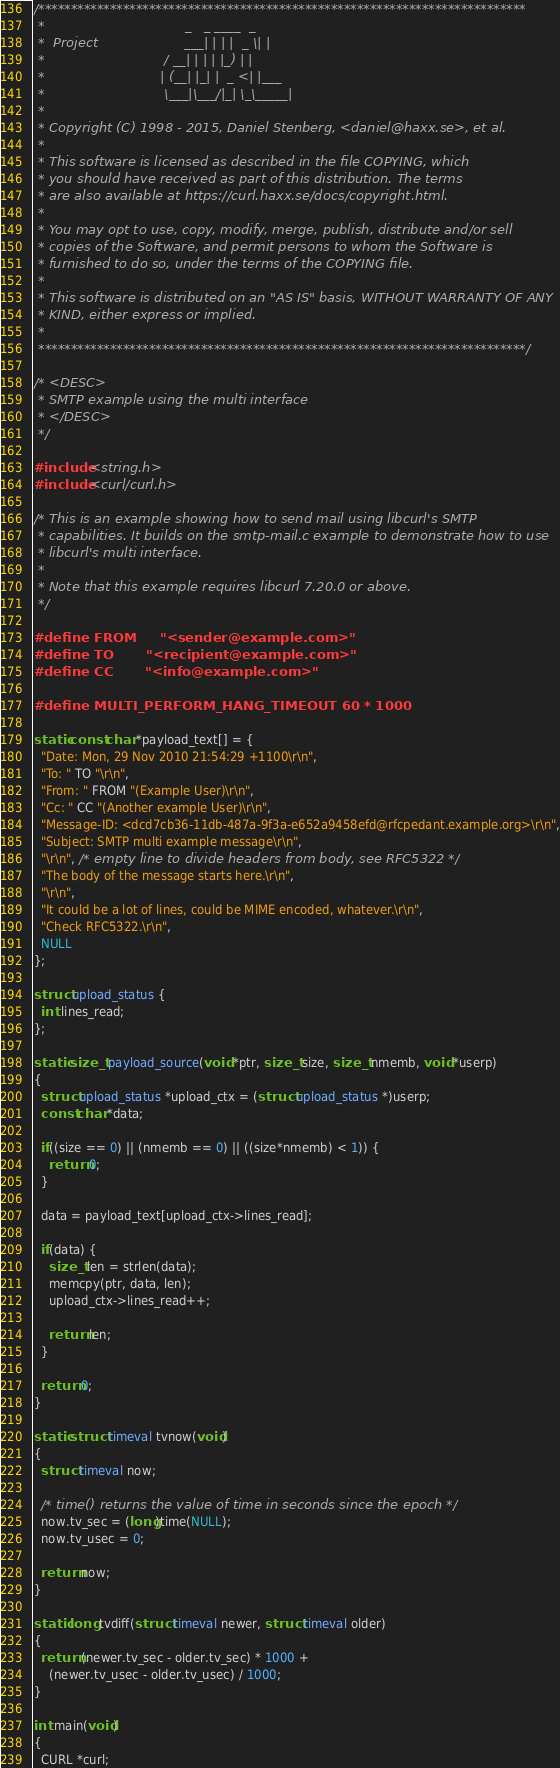Convert code to text. <code><loc_0><loc_0><loc_500><loc_500><_C_>/***************************************************************************
 *                                  _   _ ____  _
 *  Project                     ___| | | |  _ \| |
 *                             / __| | | | |_) | |
 *                            | (__| |_| |  _ <| |___
 *                             \___|\___/|_| \_\_____|
 *
 * Copyright (C) 1998 - 2015, Daniel Stenberg, <daniel@haxx.se>, et al.
 *
 * This software is licensed as described in the file COPYING, which
 * you should have received as part of this distribution. The terms
 * are also available at https://curl.haxx.se/docs/copyright.html.
 *
 * You may opt to use, copy, modify, merge, publish, distribute and/or sell
 * copies of the Software, and permit persons to whom the Software is
 * furnished to do so, under the terms of the COPYING file.
 *
 * This software is distributed on an "AS IS" basis, WITHOUT WARRANTY OF ANY
 * KIND, either express or implied.
 *
 ***************************************************************************/

/* <DESC>
 * SMTP example using the multi interface
 * </DESC>
 */

#include <string.h>
#include <curl/curl.h>

/* This is an example showing how to send mail using libcurl's SMTP
 * capabilities. It builds on the smtp-mail.c example to demonstrate how to use
 * libcurl's multi interface.
 *
 * Note that this example requires libcurl 7.20.0 or above.
 */

#define FROM     "<sender@example.com>"
#define TO       "<recipient@example.com>"
#define CC       "<info@example.com>"

#define MULTI_PERFORM_HANG_TIMEOUT 60 * 1000

static const char *payload_text[] = {
  "Date: Mon, 29 Nov 2010 21:54:29 +1100\r\n",
  "To: " TO "\r\n",
  "From: " FROM "(Example User)\r\n",
  "Cc: " CC "(Another example User)\r\n",
  "Message-ID: <dcd7cb36-11db-487a-9f3a-e652a9458efd@rfcpedant.example.org>\r\n",
  "Subject: SMTP multi example message\r\n",
  "\r\n", /* empty line to divide headers from body, see RFC5322 */
  "The body of the message starts here.\r\n",
  "\r\n",
  "It could be a lot of lines, could be MIME encoded, whatever.\r\n",
  "Check RFC5322.\r\n",
  NULL
};

struct upload_status {
  int lines_read;
};

static size_t payload_source(void *ptr, size_t size, size_t nmemb, void *userp)
{
  struct upload_status *upload_ctx = (struct upload_status *)userp;
  const char *data;

  if((size == 0) || (nmemb == 0) || ((size*nmemb) < 1)) {
    return 0;
  }

  data = payload_text[upload_ctx->lines_read];

  if(data) {
    size_t len = strlen(data);
    memcpy(ptr, data, len);
    upload_ctx->lines_read++;

    return len;
  }

  return 0;
}

static struct timeval tvnow(void)
{
  struct timeval now;

  /* time() returns the value of time in seconds since the epoch */
  now.tv_sec = (long)time(NULL);
  now.tv_usec = 0;

  return now;
}

static long tvdiff(struct timeval newer, struct timeval older)
{
  return (newer.tv_sec - older.tv_sec) * 1000 +
    (newer.tv_usec - older.tv_usec) / 1000;
}

int main(void)
{
  CURL *curl;</code> 